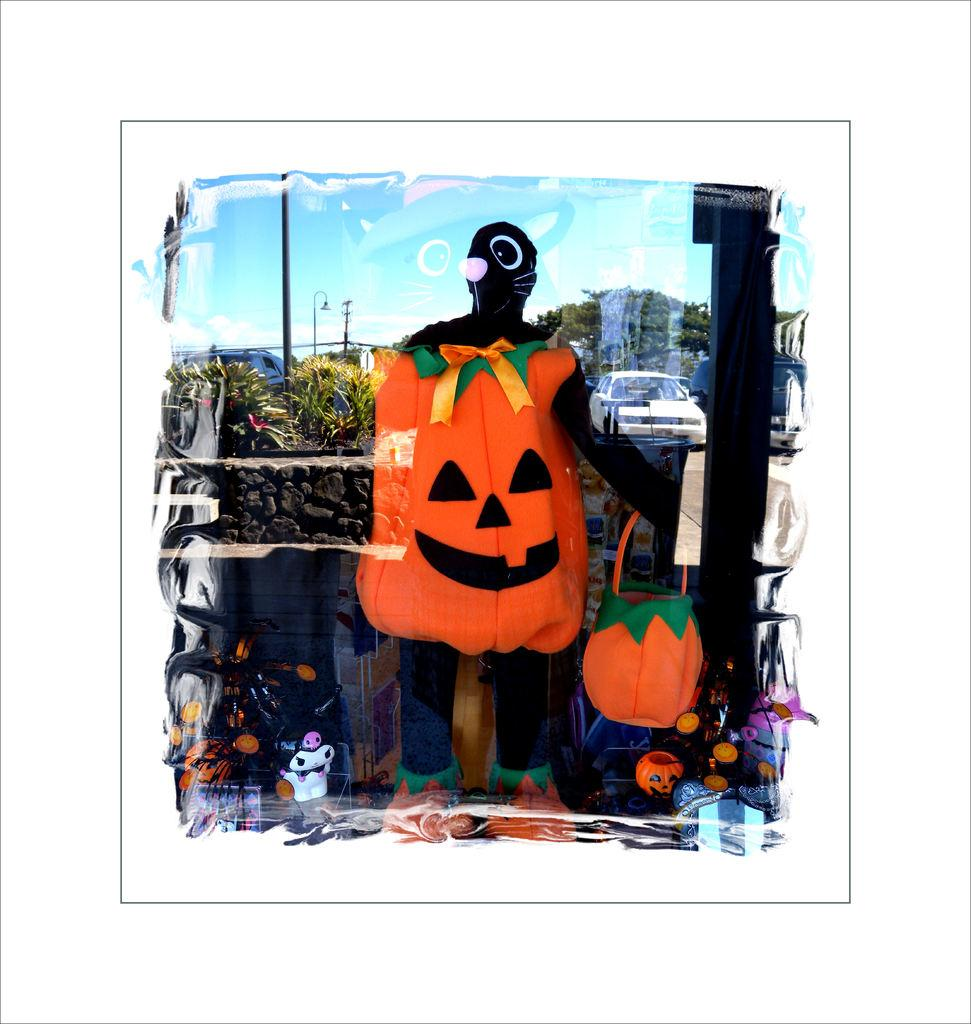Who or what is the main subject in the image? There is a person in the image. What is the person holding in the image? The person is holding a basket. What can be seen in the background of the image? There are trees, cars, poles, and the sky visible in the background of the image. What type of grass is growing on the person's head in the image? There is no grass growing on the person's head in the image. What color is the spot on the person's shirt in the image? There is no spot visible on the person's shirt in the image. 